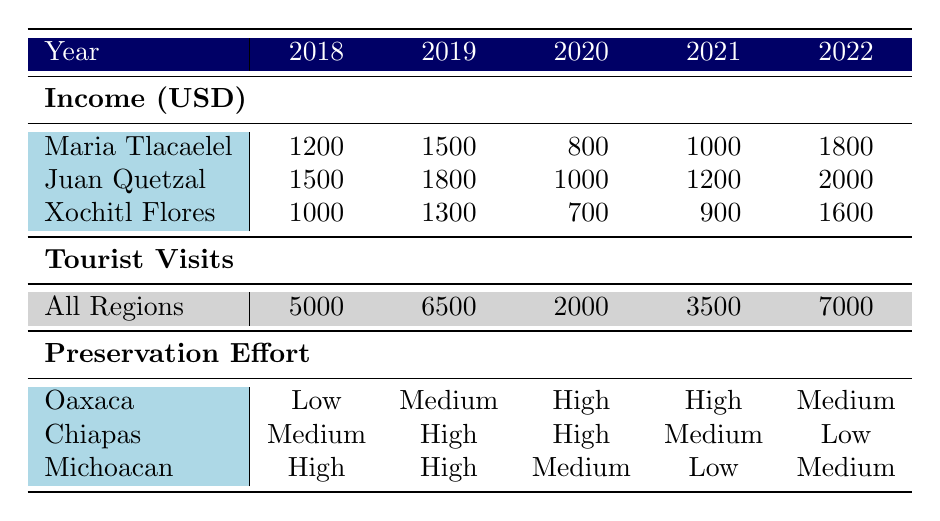What was the highest income reported for Maria Tlacaelel over the past five years? Looking at the "Income (USD)" row for Maria Tlacaelel, the values are 1200, 1500, 800, 1000, and 1800. The highest value among these is 1800 in 2022.
Answer: 1800 What was the total number of tourist visits to Chiapas in 2021? The table shows that in 2021, the number of tourist visits to Chiapas was 3500.
Answer: 3500 Did Xochitl Flores' income increase every year from 2018 to 2022? The income figures for Xochitl Flores are 1000 in 2018, 1300 in 2019, 700 in 2020, 900 in 2021, and 1600 in 2022. The income decreased from 2019 to 2020, so it did not increase every year.
Answer: No What was the average income of Juan Quetzal over the five years? Juan Quetzal's income figures are 1500, 1800, 1000, 1200, and 2000. The total income is 1500 + 1800 + 1000 + 1200 + 2000 = 8300. To find the average, divide 8300 by the number of years, which is 5: 8300 / 5 = 1660.
Answer: 1660 In which year did the total tourist visits to all regions reach the minimum? The 'Tourist Visits' row shows the values 5000, 6500, 2000, 3500, and 7000 across the years. The minimum number is 2000, which occurs in 2020.
Answer: 2020 Which artisan had the highest income in 2022? The income for each artisan in 2022 is 1800 for Maria Tlacaelel, 2000 for Juan Quetzal, and 1600 for Xochitl Flores. The highest income noted is 2000 by Juan Quetzal.
Answer: Juan Quetzal Was there an increase in tourist visits from 2020 to 2022 for Oaxaca? The tourist visits to Oaxaca for those years are 2000 in 2020 and 7000 in 2022. There is indeed an increase of 7000 - 2000 = 5000 from 2020 to 2022.
Answer: Yes What is the difference in income between Maria Tlacaelel in 2019 and Xochitl Flores in 2021? Maria Tlacaelel earned 1500 in 2019, while Xochitl Flores earned 900 in 2021. The difference is 1500 - 900 = 600.
Answer: 600 How many artisan income values were above 1500 in the year 2022? Looking at the 2022 income values: Maria Tlacaelel (1800), Juan Quetzal (2000), and Xochitl Flores (1600). All three values are above 1500, giving a total count of 3 artisans.
Answer: 3 